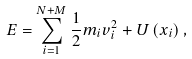Convert formula to latex. <formula><loc_0><loc_0><loc_500><loc_500>E = \sum _ { i = 1 } ^ { N + M } \frac { 1 } { 2 } m _ { i } v _ { i } ^ { 2 } + U \left ( x _ { i } \right ) ,</formula> 